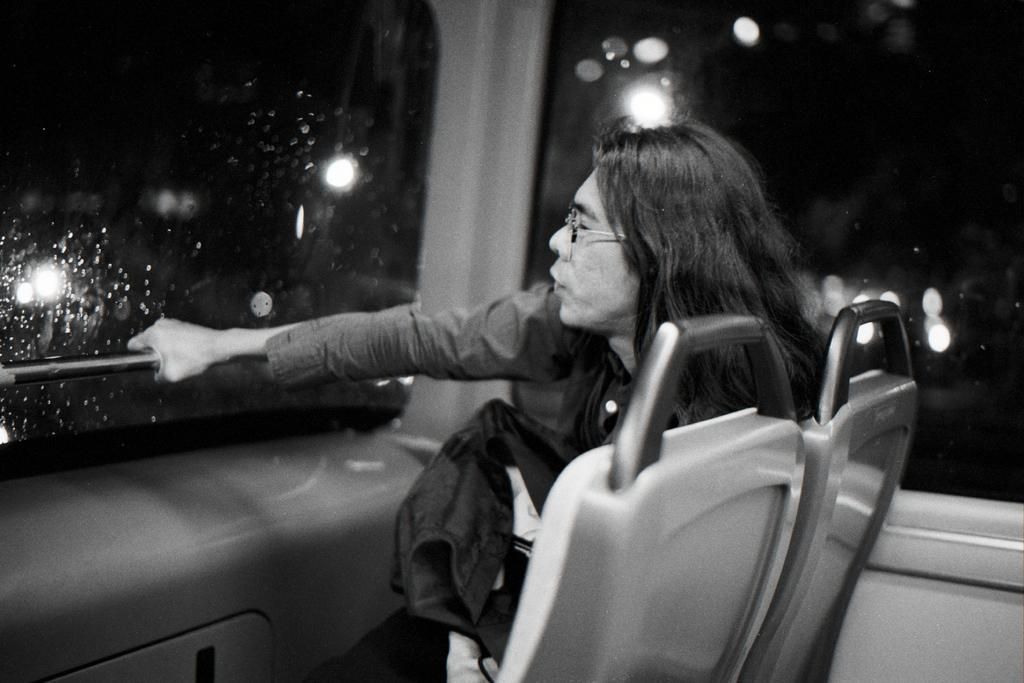What is the color scheme of the image? The image is black and white. Who is present in the image? There is a woman in the image. What is the woman doing in the image? The woman is sitting inside a vehicle and holding a rod. What else can be seen in the image? Lights are visible in the image. What type of dinosaurs can be seen in the image? There are no dinosaurs present in the image. 